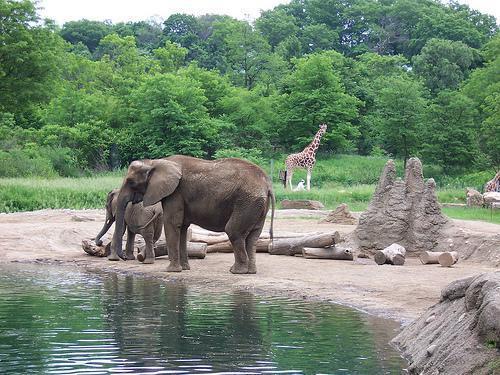How many elephants are there?
Give a very brief answer. 2. How many giraffe's are there?
Give a very brief answer. 1. 